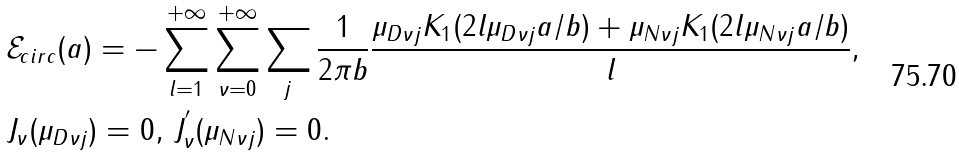Convert formula to latex. <formula><loc_0><loc_0><loc_500><loc_500>& \mathcal { E } _ { c i r c } ( a ) = - \sum _ { l = 1 } ^ { + \infty } \sum _ { \nu = 0 } ^ { + \infty } \sum _ { j } \frac { 1 } { 2 \pi b } \frac { \mu _ { D \nu j } K _ { 1 } ( 2 l \mu _ { D \nu j } a / b ) + \mu _ { N \nu j } K _ { 1 } ( 2 l \mu _ { N \nu j } a / b ) } { l } , \\ & J _ { \nu } ( \mu _ { D \nu j } ) = 0 , \, J _ { \nu } ^ { ^ { \prime } } ( \mu _ { N \nu j } ) = 0 .</formula> 